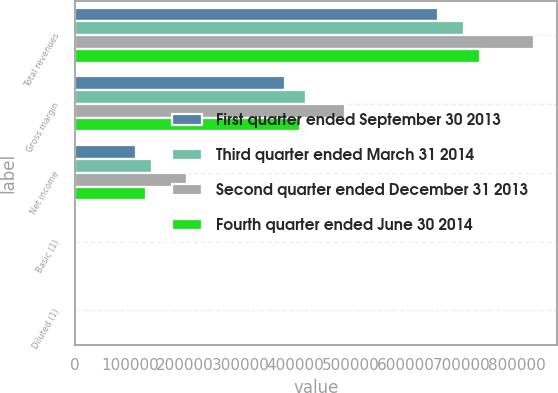Convert chart to OTSL. <chart><loc_0><loc_0><loc_500><loc_500><stacked_bar_chart><ecel><fcel>Total revenues<fcel>Gross margin<fcel>Net income<fcel>Basic (1)<fcel>Diluted (1)<nl><fcel>First quarter ended September 30 2013<fcel>658337<fcel>380680<fcel>111197<fcel>0.67<fcel>0.66<nl><fcel>Third quarter ended March 31 2014<fcel>705129<fcel>419315<fcel>139246<fcel>0.84<fcel>0.83<nl><fcel>Second quarter ended December 31 2013<fcel>831599<fcel>488773<fcel>203581<fcel>1.22<fcel>1.21<nl><fcel>Fourth quarter ended June 30 2014<fcel>734343<fcel>407678<fcel>128731<fcel>0.78<fcel>0.77<nl></chart> 